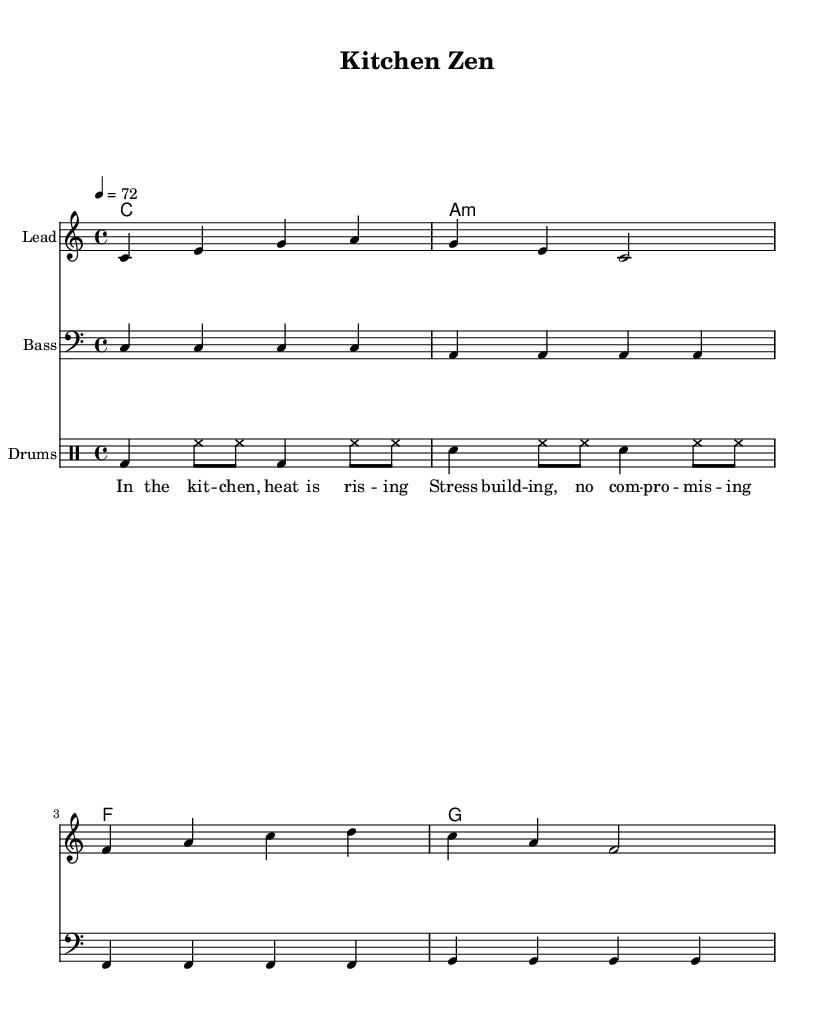What is the key signature of this music? The key signature is indicated at the beginning of the piece. Here, it shows a C major signature, which has no sharps or flats.
Answer: C major What is the time signature of this music? The time signature is shown at the beginning of the score. In this case, it is 4/4, meaning there are four beats in each measure.
Answer: 4/4 What is the tempo marking for this piece? The tempo is specified with a marking indicating the speed of the piece. Here it is indicated as 4 = 72, which means there are 72 beats per minute.
Answer: 72 How many measures are in the melody section? To find the number of measures, we can count the bars in the melody line. There are four measures visible in the melody.
Answer: 4 What type of chord is the first chord played in the harmonies? The first chord is labeled ‘c1’, which indicates a C major chord played in whole notes. This is a basic triad.
Answer: C major What rhythmic elements are featured in the drum patterns? Analyzing the drum patterns shows a combination of bass drum, snare, and hi-hat notations, which are characteristic of reggae rhythms. The bass drum and snare follow a consistent pattern.
Answer: Bass and snare What theme does the lyrics suggest in the verse? The lyrics speak about stress in the kitchen and the pressure rising, which relates to the theme of stress relief and work-life balance. It's a common theme found in reggae that emphasizes positivity amidst struggle.
Answer: Stress relief 